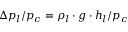<formula> <loc_0><loc_0><loc_500><loc_500>\Delta p _ { l } / p _ { c } = \rho _ { l } \cdot g \cdot h _ { l } / p _ { c }</formula> 